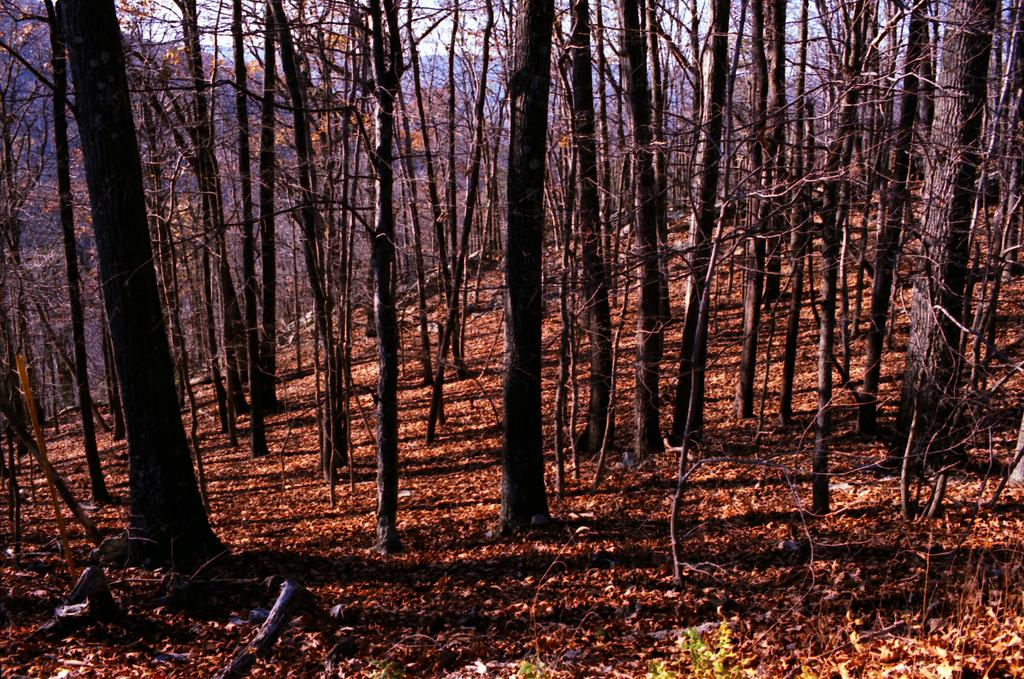What type of vegetation can be seen in the image? There are trees in the image. What is present on the ground in the image? There are dry leaves on the floor in the image. How many cherries can be seen hanging from the trees in the image? There are no cherries present in the image; only trees and dry leaves are visible. 